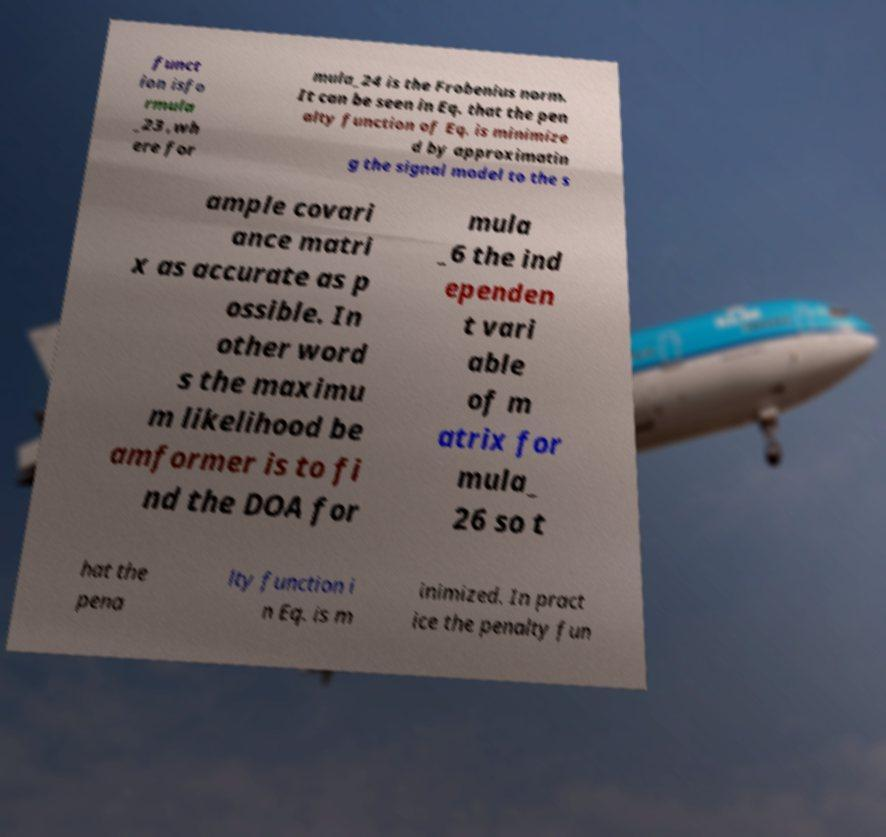Please identify and transcribe the text found in this image. funct ion isfo rmula _23 ,wh ere for mula_24 is the Frobenius norm. It can be seen in Eq. that the pen alty function of Eq. is minimize d by approximatin g the signal model to the s ample covari ance matri x as accurate as p ossible. In other word s the maximu m likelihood be amformer is to fi nd the DOA for mula _6 the ind ependen t vari able of m atrix for mula_ 26 so t hat the pena lty function i n Eq. is m inimized. In pract ice the penalty fun 